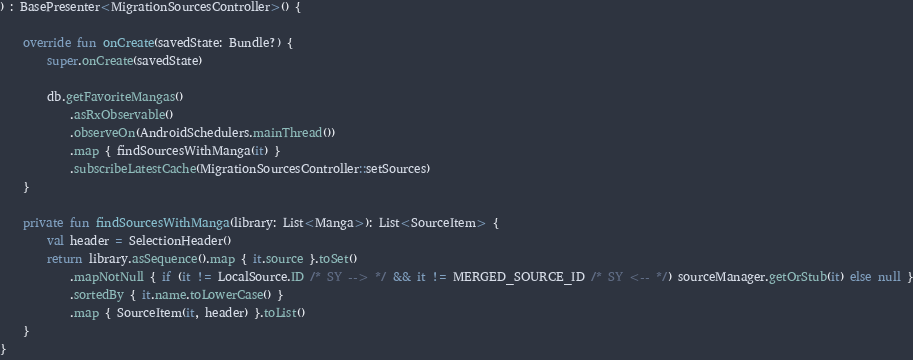<code> <loc_0><loc_0><loc_500><loc_500><_Kotlin_>) : BasePresenter<MigrationSourcesController>() {

    override fun onCreate(savedState: Bundle?) {
        super.onCreate(savedState)

        db.getFavoriteMangas()
            .asRxObservable()
            .observeOn(AndroidSchedulers.mainThread())
            .map { findSourcesWithManga(it) }
            .subscribeLatestCache(MigrationSourcesController::setSources)
    }

    private fun findSourcesWithManga(library: List<Manga>): List<SourceItem> {
        val header = SelectionHeader()
        return library.asSequence().map { it.source }.toSet()
            .mapNotNull { if (it != LocalSource.ID /* SY --> */ && it != MERGED_SOURCE_ID /* SY <-- */) sourceManager.getOrStub(it) else null }
            .sortedBy { it.name.toLowerCase() }
            .map { SourceItem(it, header) }.toList()
    }
}
</code> 